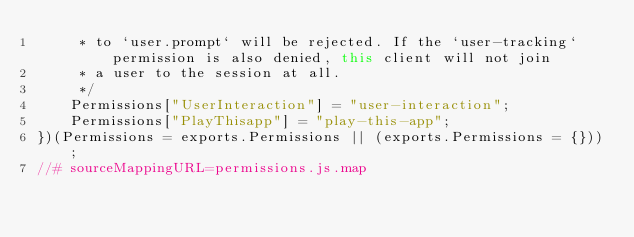<code> <loc_0><loc_0><loc_500><loc_500><_JavaScript_>     * to `user.prompt` will be rejected. If the `user-tracking` permission is also denied, this client will not join
     * a user to the session at all.
     */
    Permissions["UserInteraction"] = "user-interaction";
    Permissions["PlayThisapp"] = "play-this-app";
})(Permissions = exports.Permissions || (exports.Permissions = {}));
//# sourceMappingURL=permissions.js.map</code> 